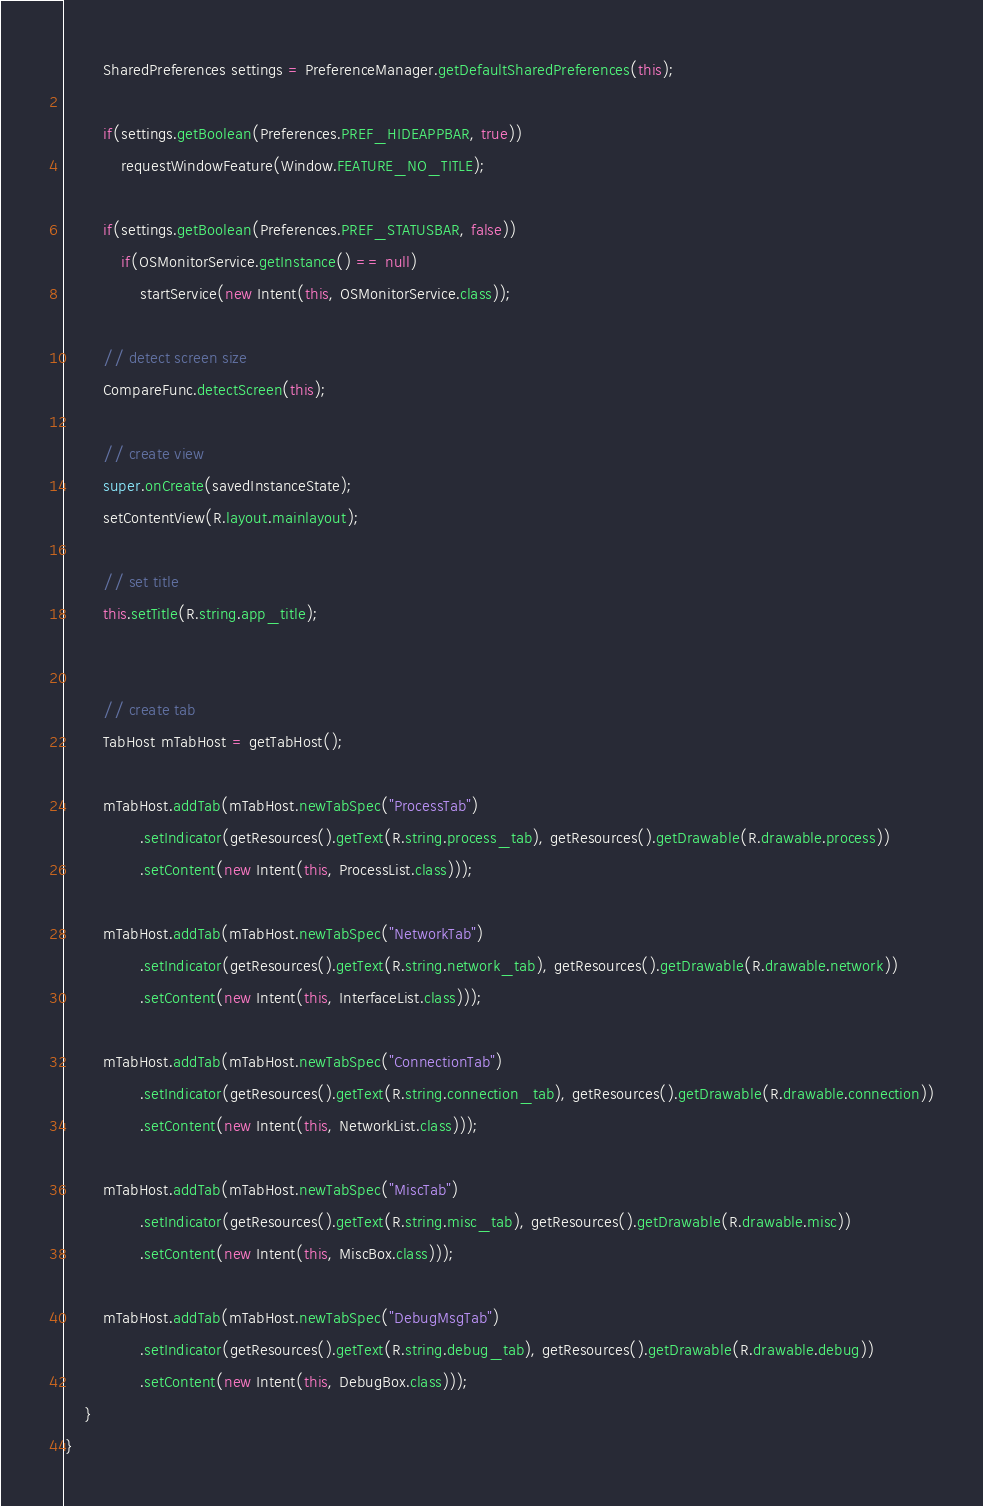<code> <loc_0><loc_0><loc_500><loc_500><_Java_>   		SharedPreferences settings = PreferenceManager.getDefaultSharedPreferences(this);
   		
   		if(settings.getBoolean(Preferences.PREF_HIDEAPPBAR, true))
   	        requestWindowFeature(Window.FEATURE_NO_TITLE);
   			
        if(settings.getBoolean(Preferences.PREF_STATUSBAR, false))
        	if(OSMonitorService.getInstance() == null)
        		startService(new Intent(this, OSMonitorService.class));
        
        // detect screen size
        CompareFunc.detectScreen(this);

        // create view
    	super.onCreate(savedInstanceState);
        setContentView(R.layout.mainlayout);

        // set title
        this.setTitle(R.string.app_title);
        
        
        // create tab
        TabHost mTabHost = getTabHost();
                 
        mTabHost.addTab(mTabHost.newTabSpec("ProcessTab")
                .setIndicator(getResources().getText(R.string.process_tab), getResources().getDrawable(R.drawable.process))
                .setContent(new Intent(this, ProcessList.class)));

        mTabHost.addTab(mTabHost.newTabSpec("NetworkTab")
                .setIndicator(getResources().getText(R.string.network_tab), getResources().getDrawable(R.drawable.network))
                .setContent(new Intent(this, InterfaceList.class)));

        mTabHost.addTab(mTabHost.newTabSpec("ConnectionTab")
                .setIndicator(getResources().getText(R.string.connection_tab), getResources().getDrawable(R.drawable.connection))
                .setContent(new Intent(this, NetworkList.class)));

        mTabHost.addTab(mTabHost.newTabSpec("MiscTab")
                .setIndicator(getResources().getText(R.string.misc_tab), getResources().getDrawable(R.drawable.misc))
                .setContent(new Intent(this, MiscBox.class)));

        mTabHost.addTab(mTabHost.newTabSpec("DebugMsgTab")
                .setIndicator(getResources().getText(R.string.debug_tab), getResources().getDrawable(R.drawable.debug))
                .setContent(new Intent(this, DebugBox.class)));
    }
}
</code> 